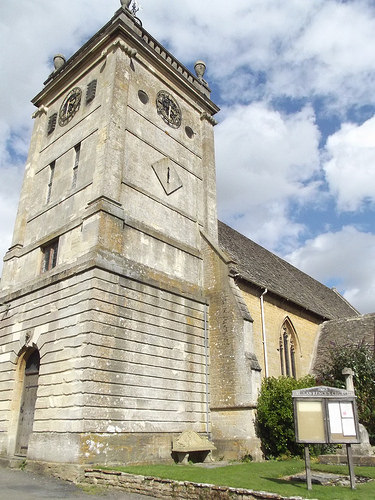<image>
Is there a buliding behind the road? No. The buliding is not behind the road. From this viewpoint, the buliding appears to be positioned elsewhere in the scene. 